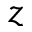Convert formula to latex. <formula><loc_0><loc_0><loc_500><loc_500>z</formula> 